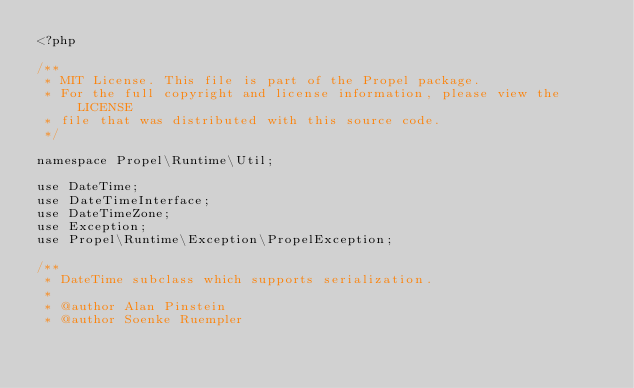Convert code to text. <code><loc_0><loc_0><loc_500><loc_500><_PHP_><?php

/**
 * MIT License. This file is part of the Propel package.
 * For the full copyright and license information, please view the LICENSE
 * file that was distributed with this source code.
 */

namespace Propel\Runtime\Util;

use DateTime;
use DateTimeInterface;
use DateTimeZone;
use Exception;
use Propel\Runtime\Exception\PropelException;

/**
 * DateTime subclass which supports serialization.
 *
 * @author Alan Pinstein
 * @author Soenke Ruempler</code> 